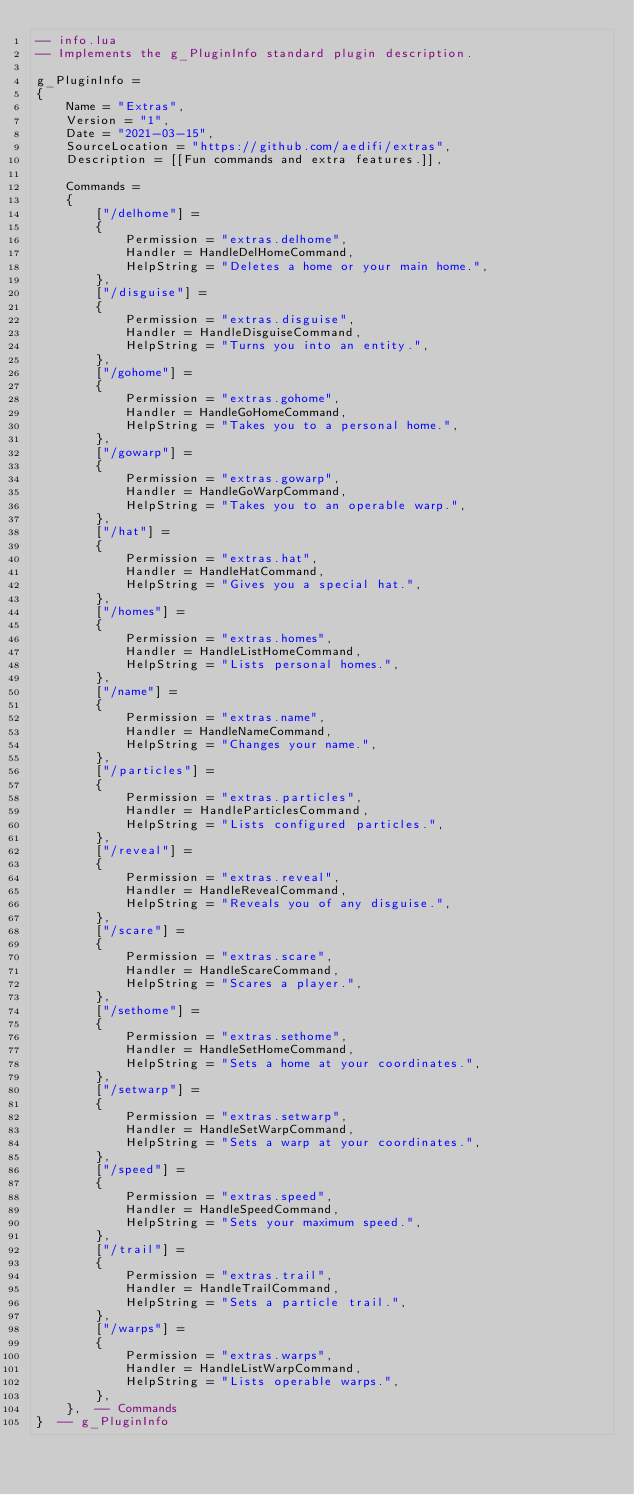<code> <loc_0><loc_0><loc_500><loc_500><_Lua_>-- info.lua
-- Implements the g_PluginInfo standard plugin description.

g_PluginInfo = 
{
	Name = "Extras",
	Version = "1",
	Date = "2021-03-15",
	SourceLocation = "https://github.com/aedifi/extras",
	Description = [[Fun commands and extra features.]],
	
	Commands =
	{
		["/delhome"] = 
		{
			Permission = "extras.delhome",
			Handler = HandleDelHomeCommand,
			HelpString = "Deletes a home or your main home.",
		},
		["/disguise"] = 
		{
			Permission = "extras.disguise",
			Handler = HandleDisguiseCommand,
			HelpString = "Turns you into an entity.",
		},
		["/gohome"] = 
		{
			Permission = "extras.gohome",
			Handler = HandleGoHomeCommand,
			HelpString = "Takes you to a personal home.",
        },
		["/gowarp"] = 
		{
			Permission = "extras.gowarp",
			Handler = HandleGoWarpCommand,
			HelpString = "Takes you to an operable warp.",
        },
		["/hat"] = 
		{
			Permission = "extras.hat",
			Handler = HandleHatCommand,
			HelpString = "Gives you a special hat.",
		},
		["/homes"] = 
		{
			Permission = "extras.homes",
			Handler = HandleListHomeCommand,
			HelpString = "Lists personal homes.",
        },
		["/name"] = 
		{
			Permission = "extras.name",
			Handler = HandleNameCommand,
			HelpString = "Changes your name.",
		},
		["/particles"] = 
		{
			Permission = "extras.particles",
			Handler = HandleParticlesCommand,
			HelpString = "Lists configured particles.",
		},
		["/reveal"] = 
		{
			Permission = "extras.reveal",
			Handler = HandleRevealCommand,
			HelpString = "Reveals you of any disguise.",
		},
		["/scare"] = 
		{
			Permission = "extras.scare",
			Handler = HandleScareCommand,
			HelpString = "Scares a player.",
		},
		["/sethome"] = 
		{
			Permission = "extras.sethome",
			Handler = HandleSetHomeCommand,
			HelpString = "Sets a home at your coordinates.",
		},
		["/setwarp"] = 
		{
			Permission = "extras.setwarp",
			Handler = HandleSetWarpCommand,
			HelpString = "Sets a warp at your coordinates.",
		},
		["/speed"] = 
		{
			Permission = "extras.speed",
			Handler = HandleSpeedCommand,
			HelpString = "Sets your maximum speed.",
		},
		["/trail"] = 
		{
			Permission = "extras.trail",
			Handler = HandleTrailCommand,
			HelpString = "Sets a particle trail.",
		},
		["/warps"] = 
		{
			Permission = "extras.warps",
			Handler = HandleListWarpCommand,
			HelpString = "Lists operable warps.",
        },
	},  -- Commands
}  -- g_PluginInfo
</code> 